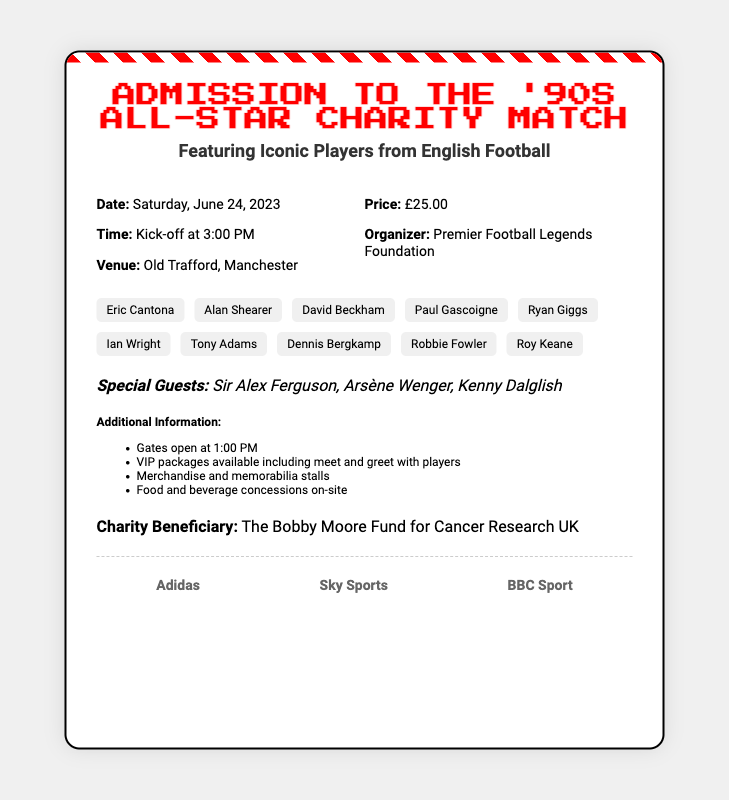What is the date of the event? The date of the event is specified in the event details section.
Answer: Saturday, June 24, 2023 What time does the match kick off? The time for kick-off is provided in the event details section.
Answer: 3:00 PM What is the ticket price? The document states the price of the ticket in the event details.
Answer: £25.00 Where is the event taking place? The venue for the event is mentioned in the event details.
Answer: Old Trafford, Manchester Who is the charity beneficiary? The charity beneficiary is listed at the bottom of the ticket information.
Answer: The Bobby Moore Fund for Cancer Research UK Which players are featured in the match? The list of featured players is shown in the featured players section.
Answer: Eric Cantona, Alan Shearer, David Beckham, Paul Gascoigne, Ryan Giggs, Ian Wright, Tony Adams, Dennis Bergkamp, Robbie Fowler, Roy Keane How many special guests are listed? The document mentions the special guests in one section.
Answer: Three What time do the gates open? The opening time for the gates is stated in the additional information section.
Answer: 1:00 PM What organization is hosting the event? The organizer of the event is mentioned in the event details.
Answer: Premier Football Legends Foundation 